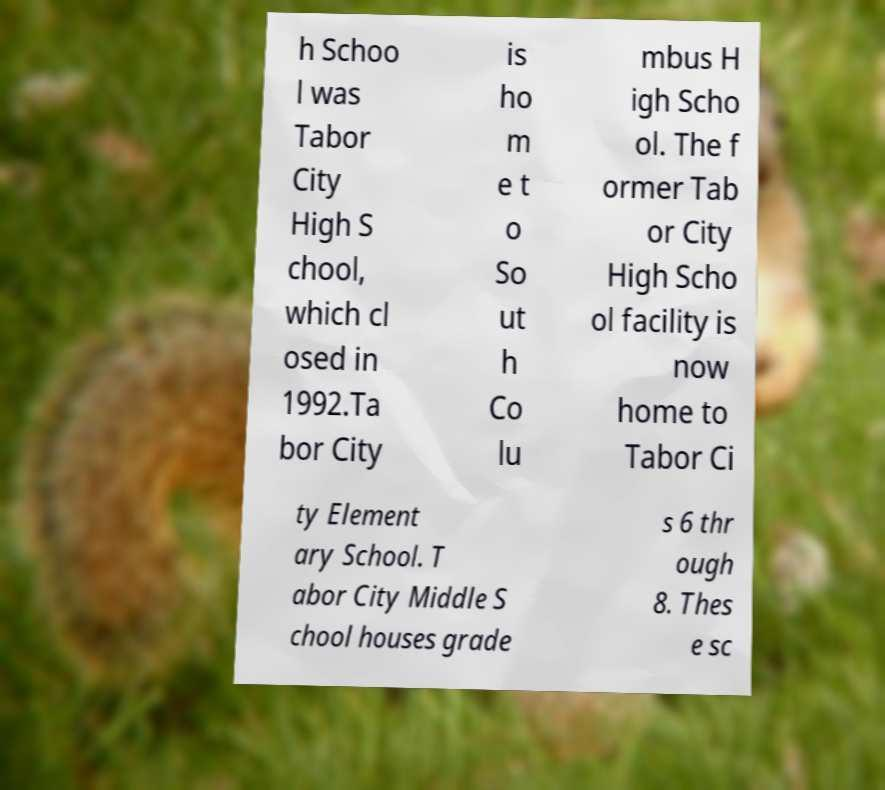Please read and relay the text visible in this image. What does it say? h Schoo l was Tabor City High S chool, which cl osed in 1992.Ta bor City is ho m e t o So ut h Co lu mbus H igh Scho ol. The f ormer Tab or City High Scho ol facility is now home to Tabor Ci ty Element ary School. T abor City Middle S chool houses grade s 6 thr ough 8. Thes e sc 